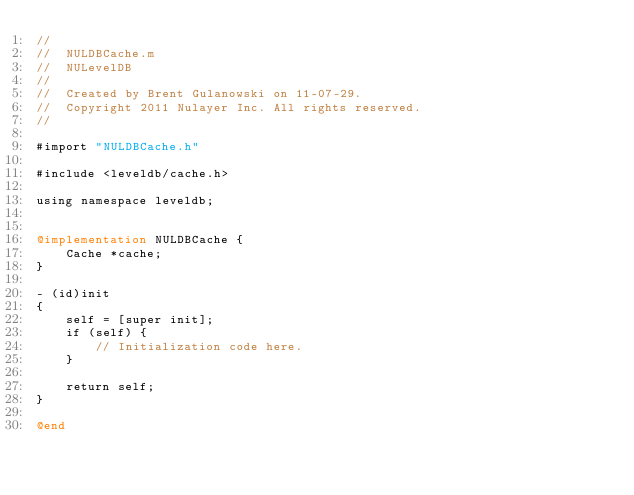Convert code to text. <code><loc_0><loc_0><loc_500><loc_500><_ObjectiveC_>//
//  NULDBCache.m
//  NULevelDB
//
//  Created by Brent Gulanowski on 11-07-29.
//  Copyright 2011 Nulayer Inc. All rights reserved.
//

#import "NULDBCache.h"

#include <leveldb/cache.h>

using namespace leveldb;


@implementation NULDBCache {
    Cache *cache;
}

- (id)init
{
    self = [super init];
    if (self) {
        // Initialization code here.
    }
    
    return self;
}

@end
</code> 